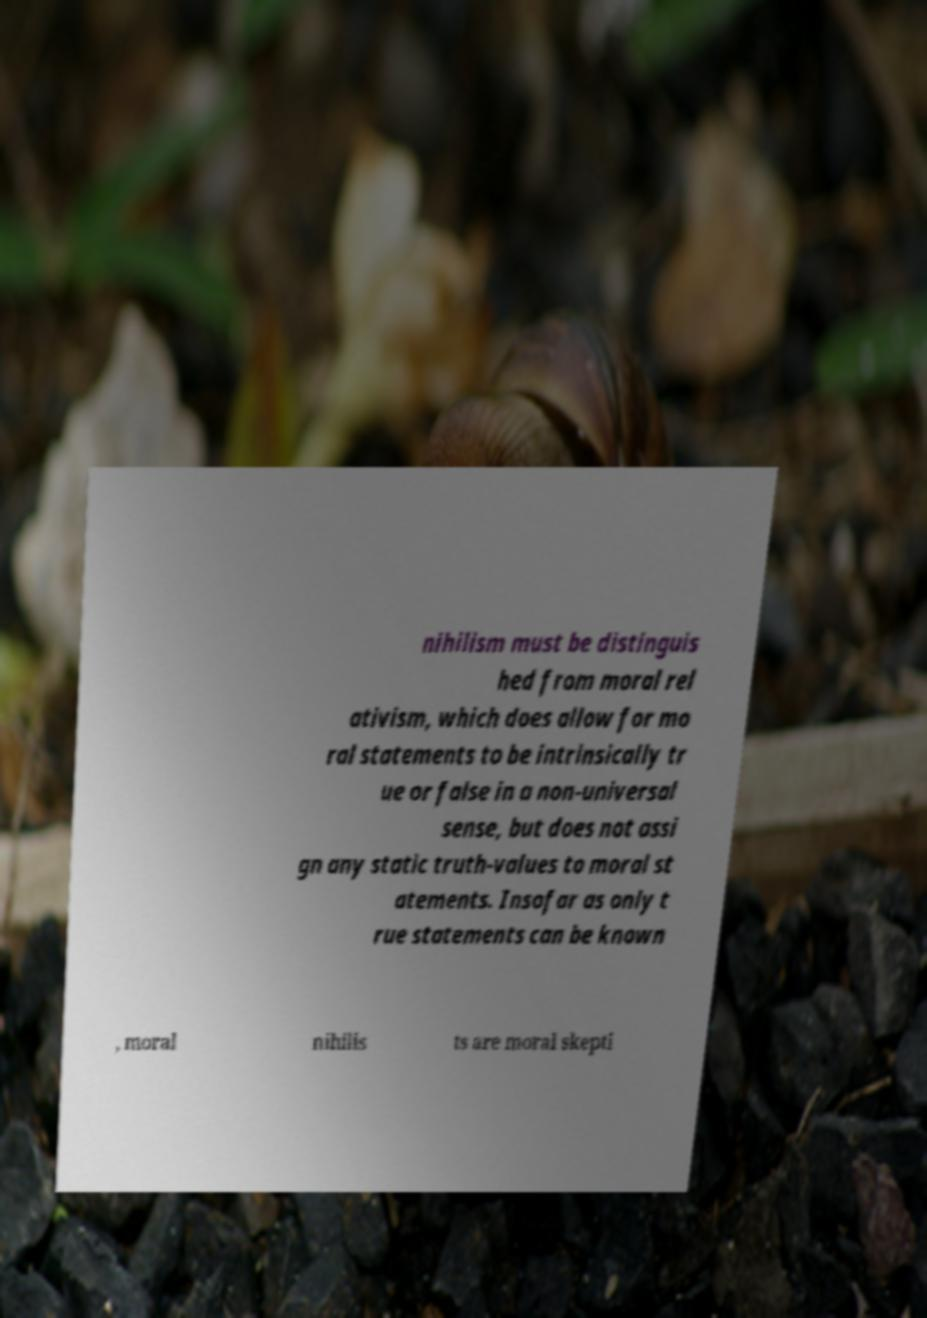There's text embedded in this image that I need extracted. Can you transcribe it verbatim? nihilism must be distinguis hed from moral rel ativism, which does allow for mo ral statements to be intrinsically tr ue or false in a non-universal sense, but does not assi gn any static truth-values to moral st atements. Insofar as only t rue statements can be known , moral nihilis ts are moral skepti 